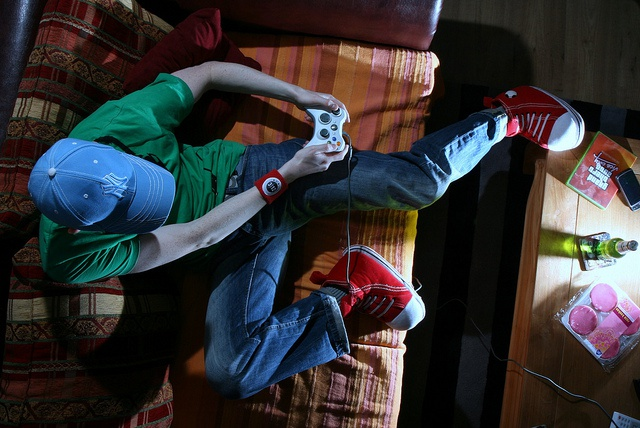Describe the objects in this image and their specific colors. I can see couch in black, maroon, and brown tones, people in black, teal, navy, and blue tones, dining table in black, lightgray, maroon, and olive tones, remote in black, lightblue, and blue tones, and bottle in black, darkgray, darkgreen, and gray tones in this image. 